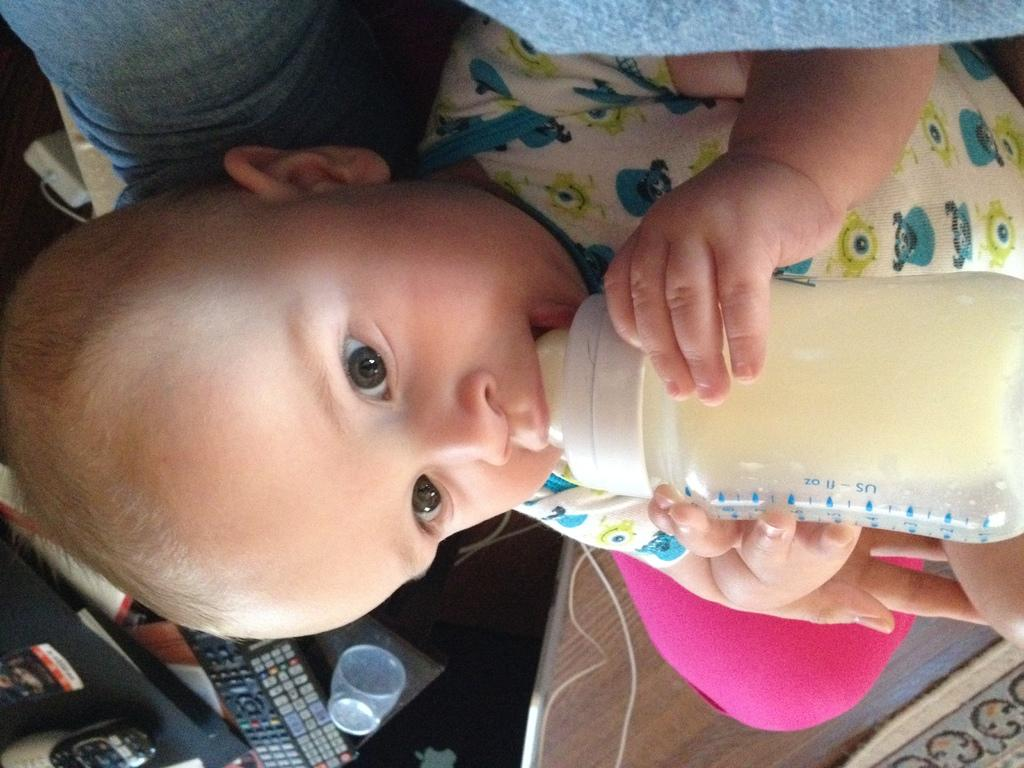What is the main subject of the image? There is a baby in the image. What is the baby doing in the image? The baby is drinking milk. What can be seen in the background of the image? There is a remote and a glass on a table in the background of the image. What type of coil is being used by the baby to breathe in the image? There is no coil or any breathing apparatus present in the image; the baby is simply drinking milk. 